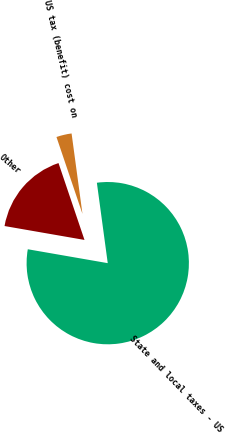Convert chart. <chart><loc_0><loc_0><loc_500><loc_500><pie_chart><fcel>State and local taxes - US<fcel>US tax (benefit) cost on<fcel>Other<nl><fcel>79.88%<fcel>3.05%<fcel>17.07%<nl></chart> 